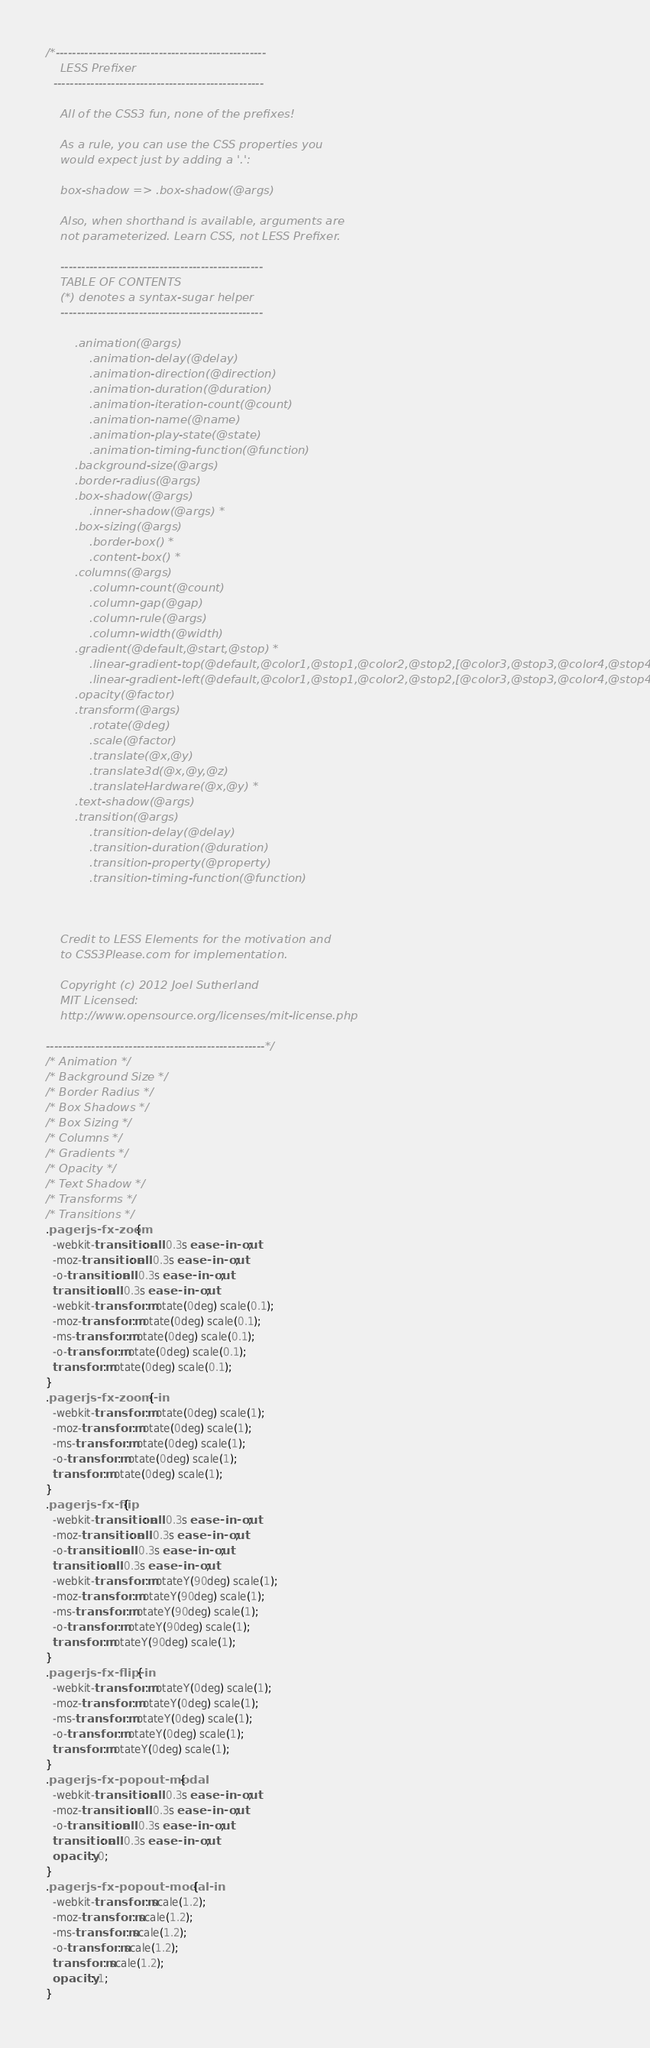<code> <loc_0><loc_0><loc_500><loc_500><_CSS_>/*---------------------------------------------------
    LESS Prefixer
  ---------------------------------------------------
    
    All of the CSS3 fun, none of the prefixes!

    As a rule, you can use the CSS properties you
    would expect just by adding a '.':

    box-shadow => .box-shadow(@args)

    Also, when shorthand is available, arguments are
    not parameterized. Learn CSS, not LESS Prefixer.

    -------------------------------------------------
    TABLE OF CONTENTS
    (*) denotes a syntax-sugar helper
    -------------------------------------------------

        .animation(@args)
            .animation-delay(@delay)
            .animation-direction(@direction)
            .animation-duration(@duration)
            .animation-iteration-count(@count)
            .animation-name(@name)
            .animation-play-state(@state)
            .animation-timing-function(@function)
        .background-size(@args)
        .border-radius(@args)
        .box-shadow(@args)
            .inner-shadow(@args) *
        .box-sizing(@args)
            .border-box() *
            .content-box() *
        .columns(@args)
            .column-count(@count)
            .column-gap(@gap)
            .column-rule(@args)
            .column-width(@width)
        .gradient(@default,@start,@stop) *
            .linear-gradient-top(@default,@color1,@stop1,@color2,@stop2,[@color3,@stop3,@color4,@stop4])*
            .linear-gradient-left(@default,@color1,@stop1,@color2,@stop2,[@color3,@stop3,@color4,@stop4])*
        .opacity(@factor)
        .transform(@args)
            .rotate(@deg)
            .scale(@factor)
            .translate(@x,@y)
            .translate3d(@x,@y,@z)
            .translateHardware(@x,@y) *
        .text-shadow(@args)
        .transition(@args)
            .transition-delay(@delay)
            .transition-duration(@duration)
            .transition-property(@property)
            .transition-timing-function(@function)



    Credit to LESS Elements for the motivation and
    to CSS3Please.com for implementation.

    Copyright (c) 2012 Joel Sutherland
    MIT Licensed:
    http://www.opensource.org/licenses/mit-license.php

-----------------------------------------------------*/
/* Animation */
/* Background Size */
/* Border Radius */
/* Box Shadows */
/* Box Sizing */
/* Columns */
/* Gradients */
/* Opacity */
/* Text Shadow */
/* Transforms */
/* Transitions */
.pagerjs-fx-zoom {
  -webkit-transition: all 0.3s ease-in-out;
  -moz-transition: all 0.3s ease-in-out;
  -o-transition: all 0.3s ease-in-out;
  transition: all 0.3s ease-in-out;
  -webkit-transform: rotate(0deg) scale(0.1);
  -moz-transform: rotate(0deg) scale(0.1);
  -ms-transform: rotate(0deg) scale(0.1);
  -o-transform: rotate(0deg) scale(0.1);
  transform: rotate(0deg) scale(0.1);
}
.pagerjs-fx-zoom-in {
  -webkit-transform: rotate(0deg) scale(1);
  -moz-transform: rotate(0deg) scale(1);
  -ms-transform: rotate(0deg) scale(1);
  -o-transform: rotate(0deg) scale(1);
  transform: rotate(0deg) scale(1);
}
.pagerjs-fx-flip {
  -webkit-transition: all 0.3s ease-in-out;
  -moz-transition: all 0.3s ease-in-out;
  -o-transition: all 0.3s ease-in-out;
  transition: all 0.3s ease-in-out;
  -webkit-transform: rotateY(90deg) scale(1);
  -moz-transform: rotateY(90deg) scale(1);
  -ms-transform: rotateY(90deg) scale(1);
  -o-transform: rotateY(90deg) scale(1);
  transform: rotateY(90deg) scale(1);
}
.pagerjs-fx-flip-in {
  -webkit-transform: rotateY(0deg) scale(1);
  -moz-transform: rotateY(0deg) scale(1);
  -ms-transform: rotateY(0deg) scale(1);
  -o-transform: rotateY(0deg) scale(1);
  transform: rotateY(0deg) scale(1);
}
.pagerjs-fx-popout-modal {
  -webkit-transition: all 0.3s ease-in-out;
  -moz-transition: all 0.3s ease-in-out;
  -o-transition: all 0.3s ease-in-out;
  transition: all 0.3s ease-in-out;
  opacity: 0;
}
.pagerjs-fx-popout-modal-in {
  -webkit-transform: scale(1.2);
  -moz-transform: scale(1.2);
  -ms-transform: scale(1.2);
  -o-transform: scale(1.2);
  transform: scale(1.2);
  opacity: 1;
}
</code> 